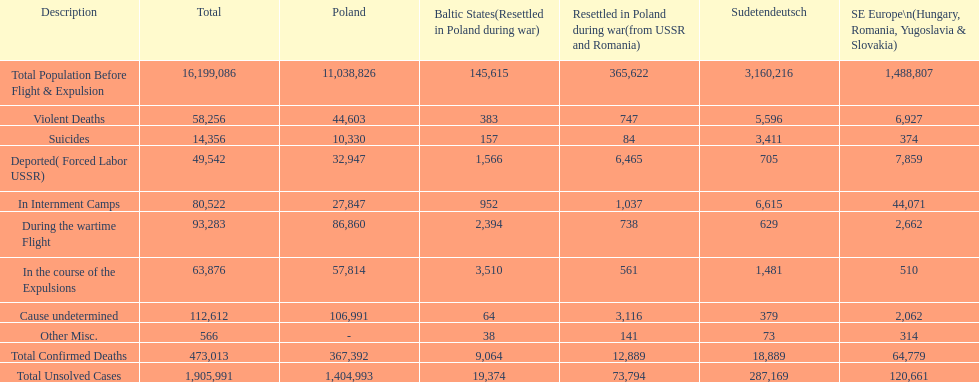What is the overall count of violent fatalities in all areas? 58,256. 